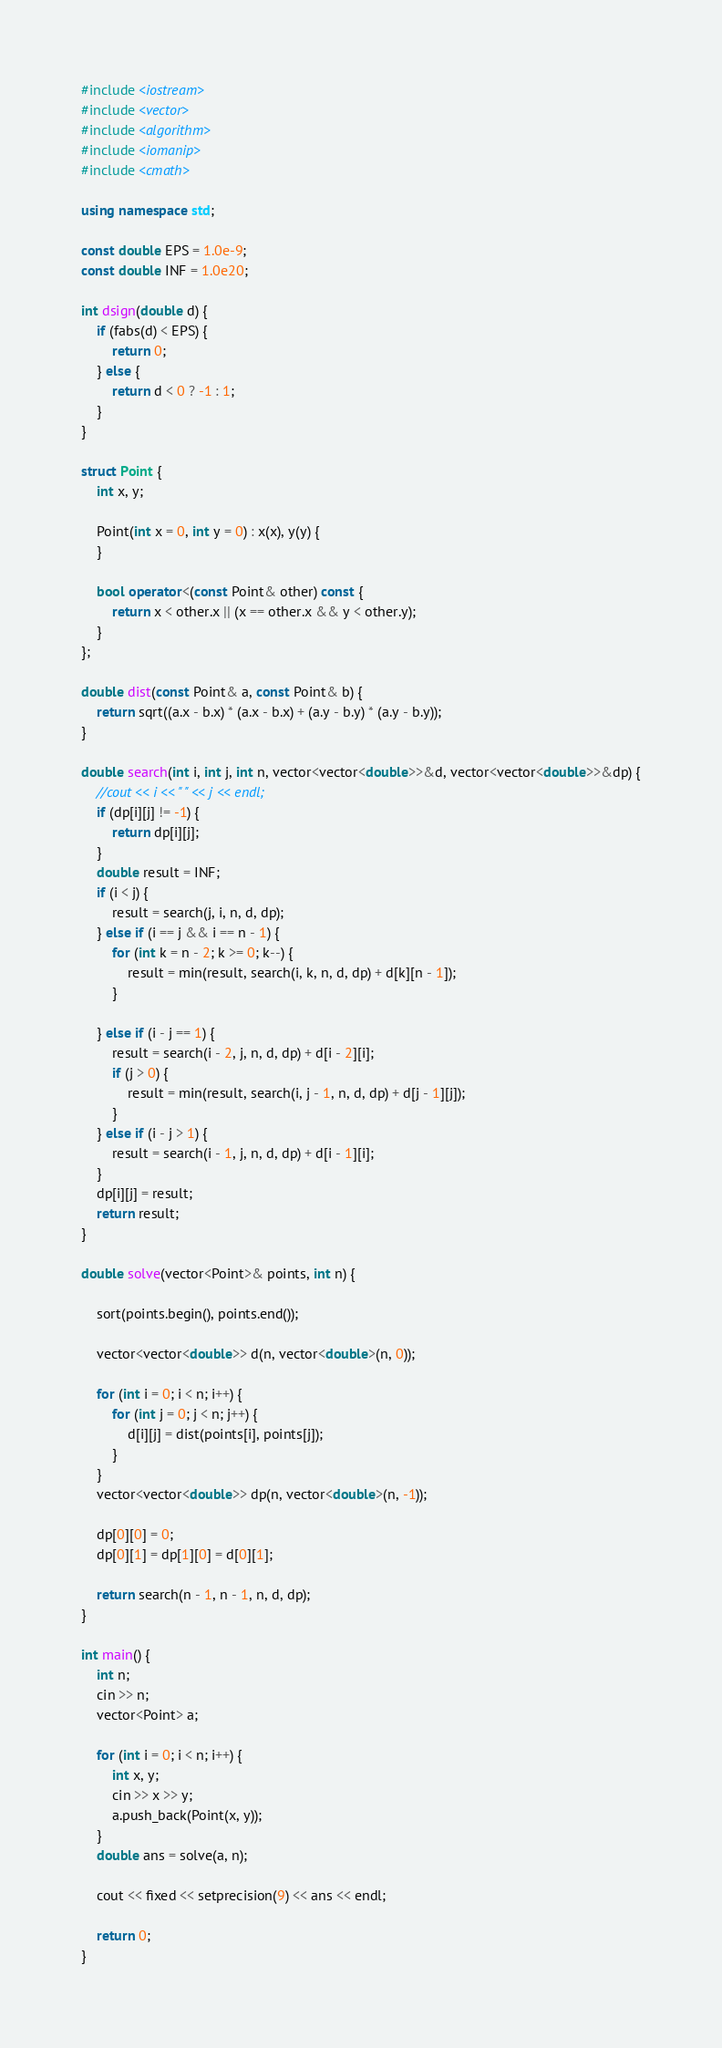Convert code to text. <code><loc_0><loc_0><loc_500><loc_500><_C++_>#include <iostream>
#include <vector>
#include <algorithm>
#include <iomanip>
#include <cmath>

using namespace std;

const double EPS = 1.0e-9;
const double INF = 1.0e20;

int dsign(double d) {
    if (fabs(d) < EPS) {
        return 0;
    } else {
        return d < 0 ? -1 : 1;
    }
}

struct Point {
    int x, y;

    Point(int x = 0, int y = 0) : x(x), y(y) {
    }

    bool operator<(const Point& other) const {
        return x < other.x || (x == other.x && y < other.y);
    }
};

double dist(const Point& a, const Point& b) {
    return sqrt((a.x - b.x) * (a.x - b.x) + (a.y - b.y) * (a.y - b.y));
}

double search(int i, int j, int n, vector<vector<double>>&d, vector<vector<double>>&dp) {
    //cout << i << " " << j << endl;
    if (dp[i][j] != -1) {
        return dp[i][j];
    }
    double result = INF;
    if (i < j) {
        result = search(j, i, n, d, dp);
    } else if (i == j && i == n - 1) {
        for (int k = n - 2; k >= 0; k--) {
            result = min(result, search(i, k, n, d, dp) + d[k][n - 1]);
        }
        
    } else if (i - j == 1) {
        result = search(i - 2, j, n, d, dp) + d[i - 2][i];
        if (j > 0) {
            result = min(result, search(i, j - 1, n, d, dp) + d[j - 1][j]);
        }
    } else if (i - j > 1) {
        result = search(i - 1, j, n, d, dp) + d[i - 1][i];
    }
    dp[i][j] = result;
    return result;
}

double solve(vector<Point>& points, int n) {

    sort(points.begin(), points.end());

    vector<vector<double>> d(n, vector<double>(n, 0));

    for (int i = 0; i < n; i++) {
        for (int j = 0; j < n; j++) {
            d[i][j] = dist(points[i], points[j]);
        }
    }
    vector<vector<double>> dp(n, vector<double>(n, -1));

    dp[0][0] = 0;
    dp[0][1] = dp[1][0] = d[0][1];

    return search(n - 1, n - 1, n, d, dp);
}

int main() {
    int n;
    cin >> n;
    vector<Point> a;

    for (int i = 0; i < n; i++) {
        int x, y;
        cin >> x >> y;
        a.push_back(Point(x, y));
    }
    double ans = solve(a, n);

    cout << fixed << setprecision(9) << ans << endl;

    return 0;
}</code> 